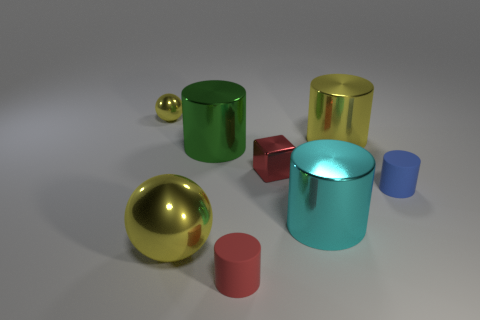Subtract all cyan cylinders. How many cylinders are left? 4 Subtract all red cylinders. How many cylinders are left? 4 Add 2 big cyan cylinders. How many objects exist? 10 Subtract all purple cylinders. Subtract all cyan balls. How many cylinders are left? 5 Subtract all spheres. How many objects are left? 6 Subtract all big gray spheres. Subtract all small blocks. How many objects are left? 7 Add 5 small yellow balls. How many small yellow balls are left? 6 Add 2 red cylinders. How many red cylinders exist? 3 Subtract 0 purple blocks. How many objects are left? 8 